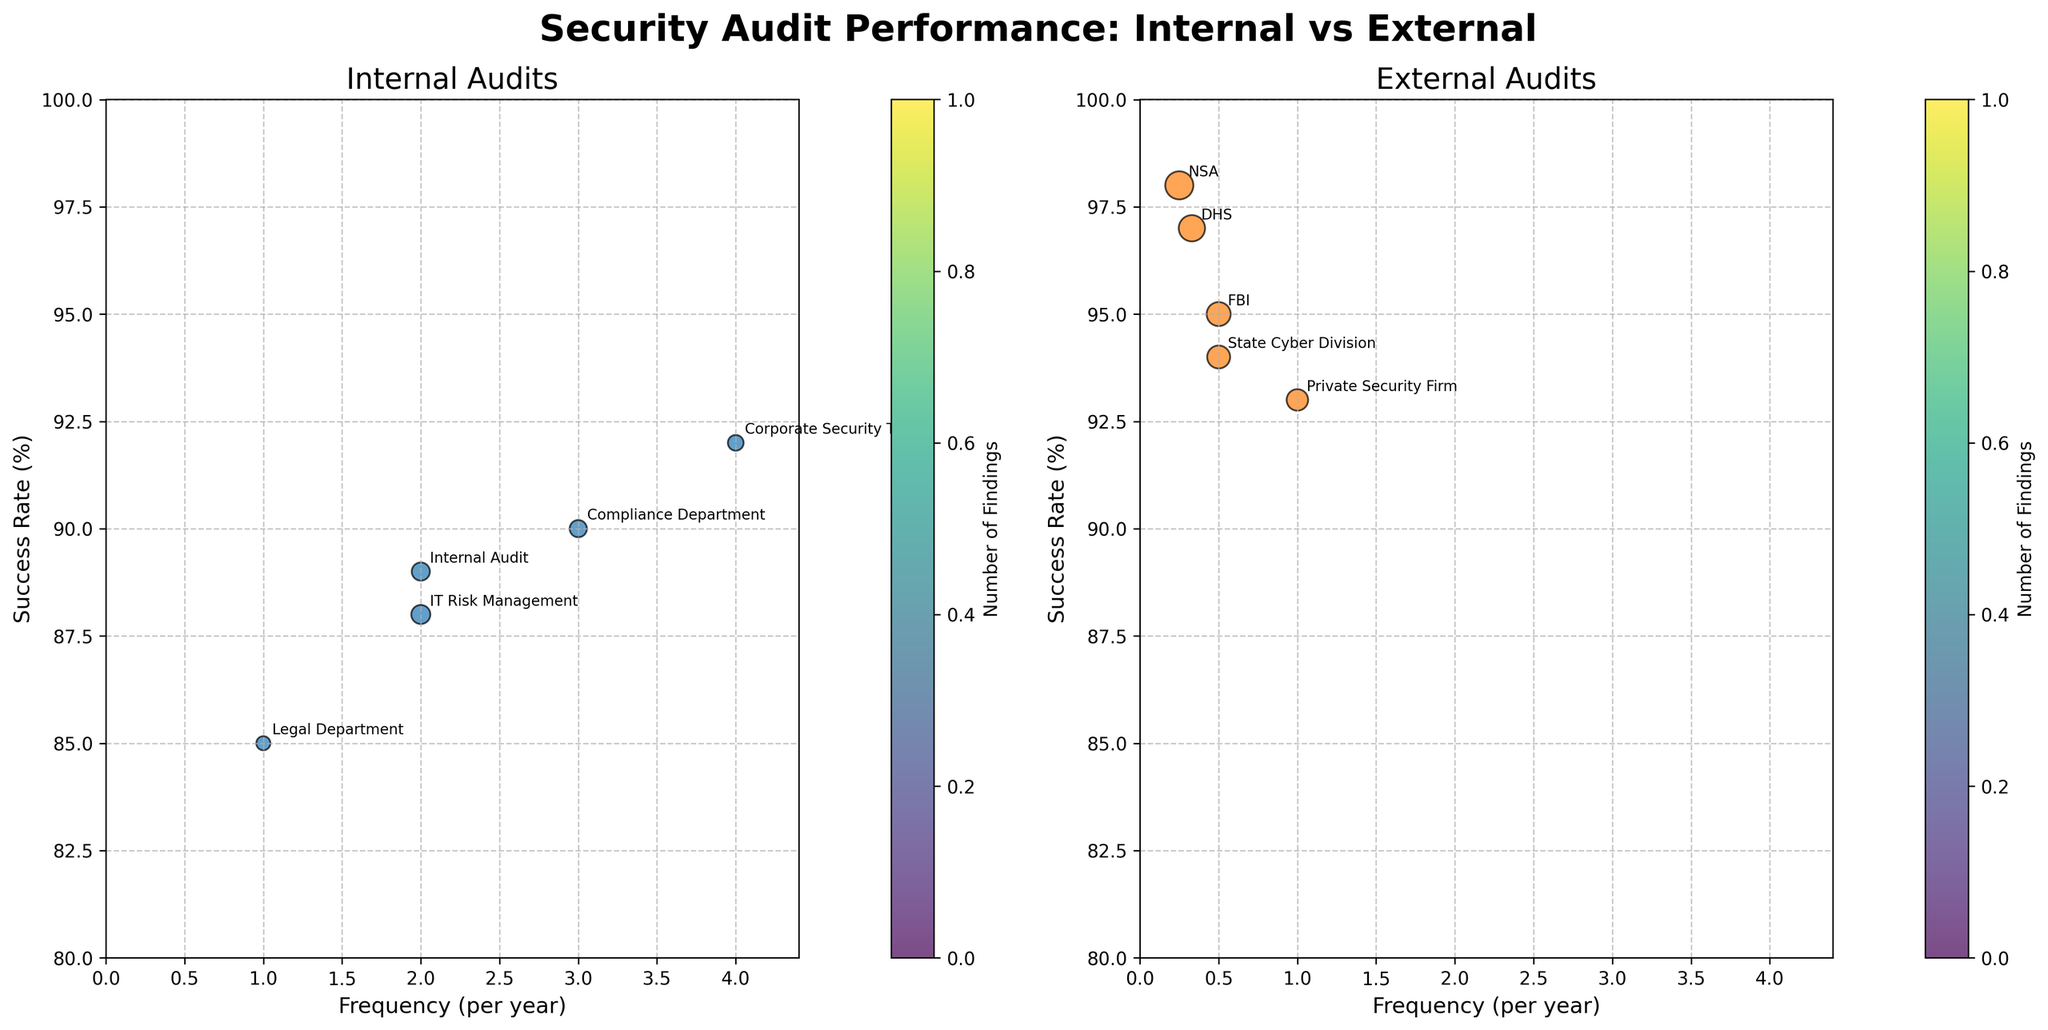How many internal audit agencies are listed in the figure? The figure shows bubble charts for internal and external audits. By looking at the subplot for internal audits, we can count the labels for internal agencies.
Answer: 5 Which external agency has the highest success rate? By examining the external audits subplot, we can identify the agency placed at the highest point on the Y-axis (Success Rate). The highest point is labeled with the NSA, which has a 98% success rate.
Answer: NSA What is the range of audit frequencies for internal agencies? Looking at the X-axis (Frequency per year) on the internal audits subplot, we can identify that the lowest frequency is 1 (Legal Department) and the highest is 4 (Corporate Security Team). The range is calculated by subtracting the lowest value from the highest value.
Answer: 1 to 4 Which category has a broader range of success rates? For internal audits, the success rates range from 85% to 92%, whereas for external audits, the success rates range from 93% to 98%. Comparing these ranges, internal audits have a broader range (7%) compared to external audits (5%).
Answer: Internal Compare the number of findings for the Corporate Security Team and the FBI. Identify the sizes of the bubbles corresponding to the Corporate Security Team and the FBI. The Corporate Security Team has 15 findings, while the FBI has 35. Thus, the FBI has more findings.
Answer: FBI What is the average success rate of external audits? Compute the average by adding the success rates of all external agencies and dividing by the number of agencies. The sum of the success rates is 95 + 97 + 98 + 93 + 94 = 477, and there are 5 external agencies. Therefore, the average success rate is 477 / 5.
Answer: 95.4% How many data points are plotted for external agencies? By counting the bubbles (data points) in the external audits subplot, we see there are 5 data points, each representing an external agency.
Answer: 5 What are the success rates for agencies conducting audits once per year? Refer to both subplots and identify agencies with a frequency of 1 per year. The agencies are the Legal Department (85%) for internal and the Private Security Firm (93%) for external audits.
Answer: 85% and 93% Which internal agency has the lowest success rate, and what is it? In the internal audits subplot, find the agency with the lowest position on the Y-axis. The Legal Department has the lowest success rate at 85%.
Answer: Legal Department What are the differences between the highest and lowest success rates for both categories? For internal audits, the highest success rate is 92% (Corporate Security Team) and the lowest is 85% (Legal Department), resulting in a difference of 7% (92 - 85). For external audits, the highest success rate is 98% (NSA) and the lowest is 93% (Private Security Firm and FBI), resulting in a difference of 5% (98 - 93).
Answer: 7% for internal, 5% for external 